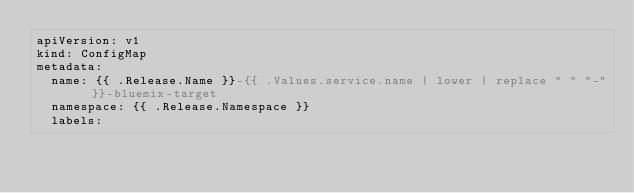Convert code to text. <code><loc_0><loc_0><loc_500><loc_500><_YAML_>apiVersion: v1
kind: ConfigMap
metadata:
  name: {{ .Release.Name }}-{{ .Values.service.name | lower | replace " " "-" }}-bluemix-target
  namespace: {{ .Release.Namespace }}
  labels:</code> 